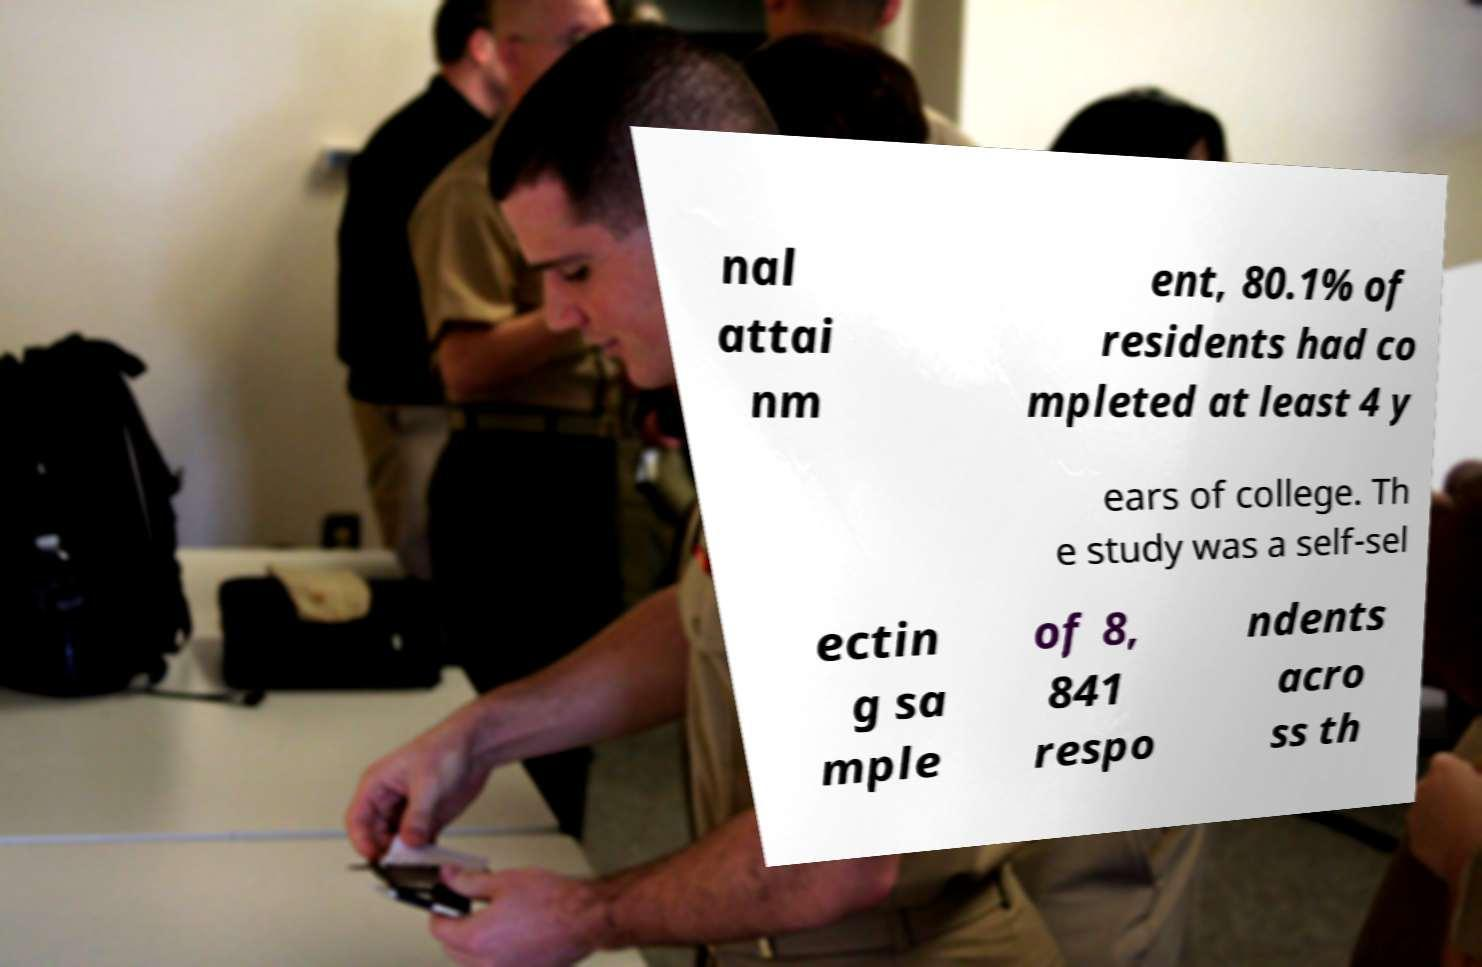For documentation purposes, I need the text within this image transcribed. Could you provide that? nal attai nm ent, 80.1% of residents had co mpleted at least 4 y ears of college. Th e study was a self-sel ectin g sa mple of 8, 841 respo ndents acro ss th 